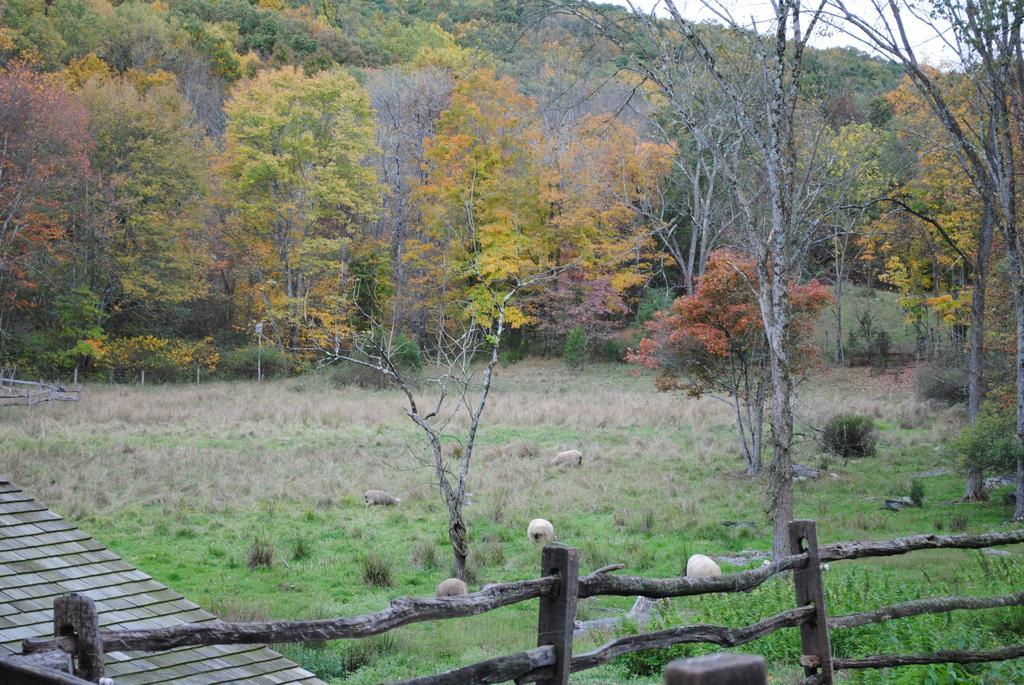Describe this image in one or two sentences. This image consists of fence, grass, stones, plants, trees, mountains and the sky. This image is taken may be during a day. 